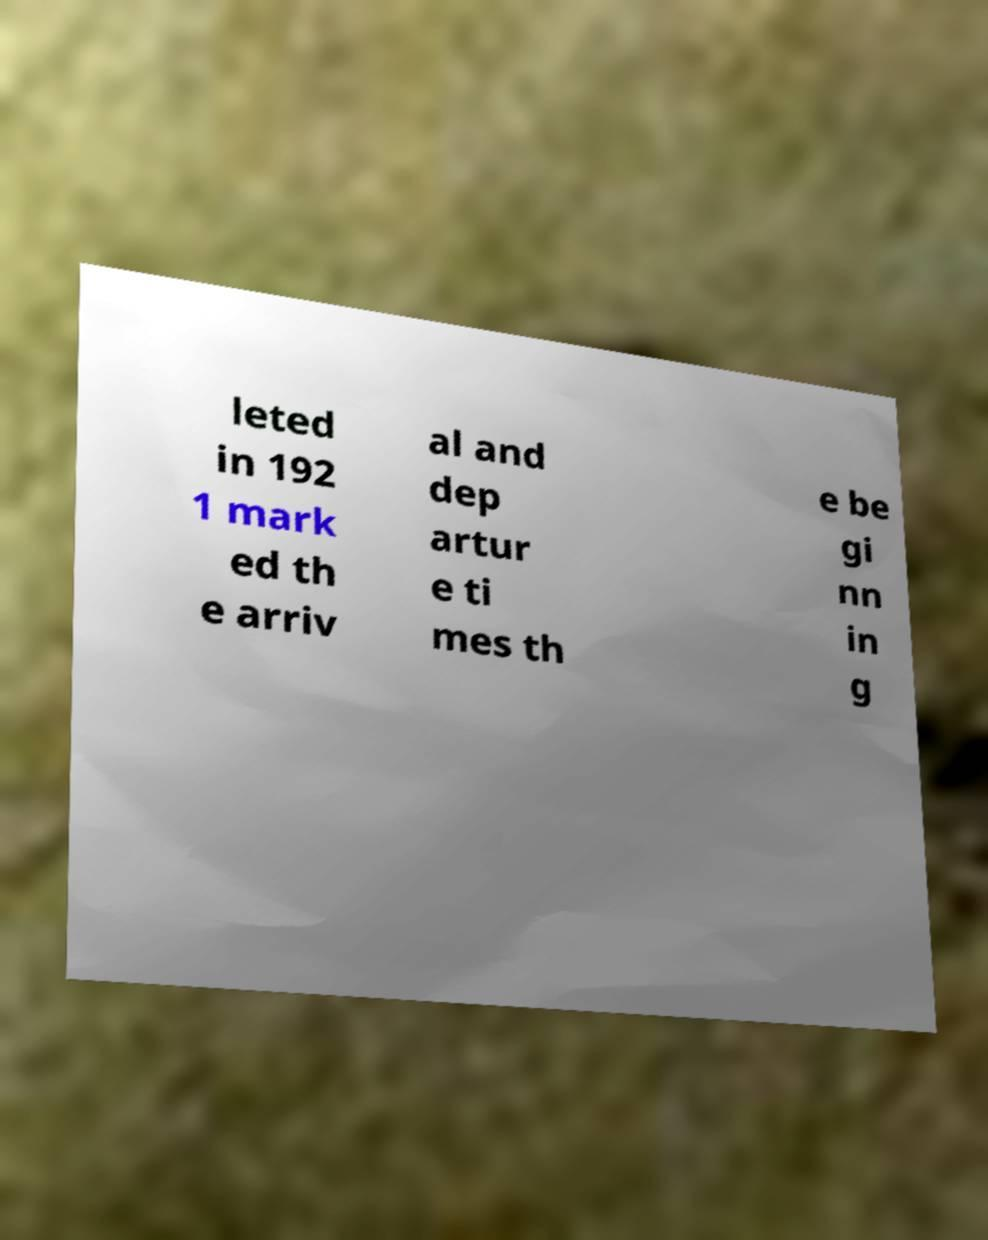Can you accurately transcribe the text from the provided image for me? leted in 192 1 mark ed th e arriv al and dep artur e ti mes th e be gi nn in g 